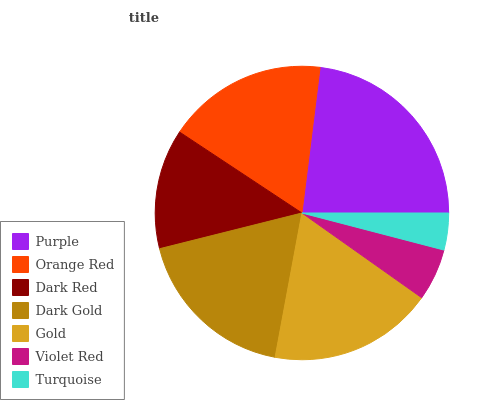Is Turquoise the minimum?
Answer yes or no. Yes. Is Purple the maximum?
Answer yes or no. Yes. Is Orange Red the minimum?
Answer yes or no. No. Is Orange Red the maximum?
Answer yes or no. No. Is Purple greater than Orange Red?
Answer yes or no. Yes. Is Orange Red less than Purple?
Answer yes or no. Yes. Is Orange Red greater than Purple?
Answer yes or no. No. Is Purple less than Orange Red?
Answer yes or no. No. Is Orange Red the high median?
Answer yes or no. Yes. Is Orange Red the low median?
Answer yes or no. Yes. Is Dark Gold the high median?
Answer yes or no. No. Is Dark Red the low median?
Answer yes or no. No. 